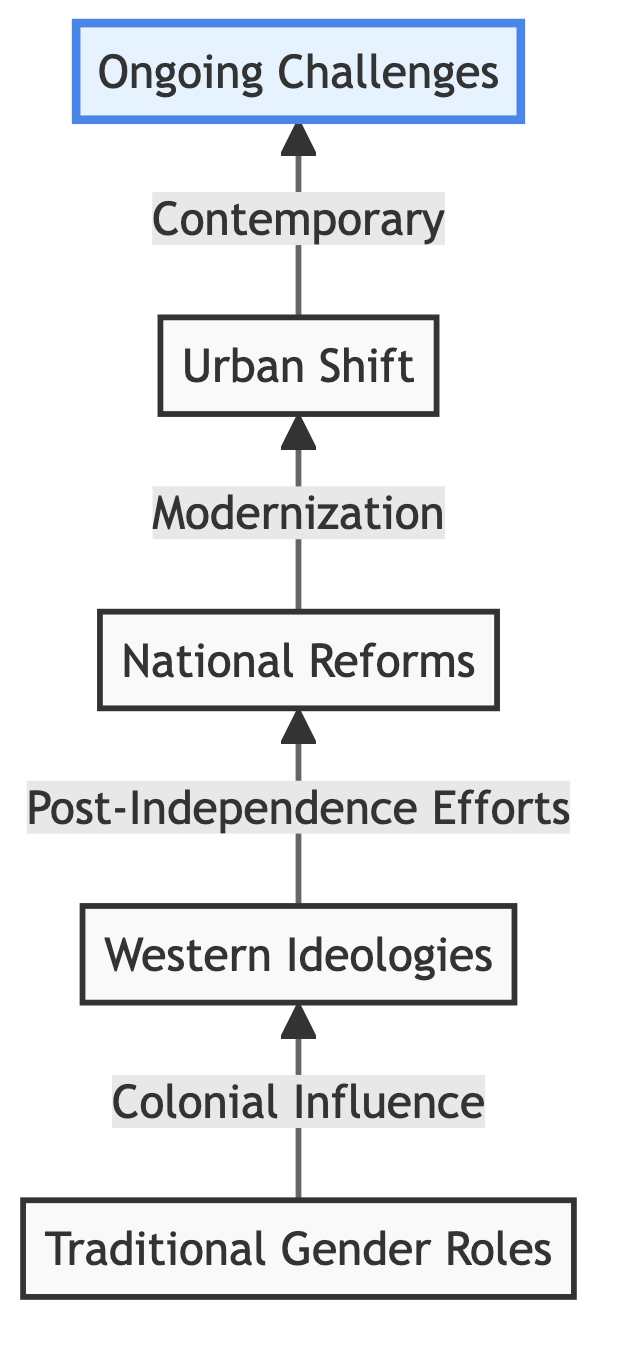What is the first stage in the diagram? The first stage in the diagram is "Traditional Gender Roles," which is indicated at the bottom of the flowchart as the starting point of the progression.
Answer: Traditional Gender Roles How many stages are depicted in the diagram? The diagram contains a total of five stages, represented by the elements arranged from bottom to top.
Answer: 5 What follows Colonial Influence in the progression? After "Colonial Influence," the next stage in the flowchart is "Post-Independence Efforts," as indicated by the upward arrow leading from one stage to the next.
Answer: Post-Independence Efforts What is the primary focus of Contemporary Challenges and Achievements? "Contemporary Challenges and Achievements" highlights ongoing struggles and significant achievements related to gender equality, reflecting the current scenario at the top of the diagram.
Answer: Ongoing struggles and achievements Which stage highlights the shift toward modern economies? The "Modernization and Urbanization" stage highlights the shift toward modern economies, representing the changes in gender dynamics as the diagram progresses upward.
Answer: Modernization and Urbanization Which element is represented as the final stage in the diagram? The final stage in the diagram is "Contemporary Challenges and Achievements," indicating the culmination of the gender role progression in Middle Eastern societies.
Answer: Contemporary Challenges and Achievements How do Colonial Influence and Post-Independence Efforts relate to each other based on the diagram? "Colonial Influence" leads directly to "Post-Independence Efforts," showing a causal relationship where colonial ideologies influence national reforms aimed at gender equality.
Answer: Causal relationship What change does the arrow from Post-Independence Efforts indicate? The arrow from "Post-Independence Efforts" to "Modernization and Urbanization" indicates a progression from legal reforms and increased access to education toward broader societal changes.
Answer: Progression toward broader societal changes What does the arrow pointing upwards signify in the context of the diagram? The arrow pointing upwards signifies the progression of gender roles through different stages, indicating an upward movement toward increasing gender equality and achievements.
Answer: Progression of gender roles 